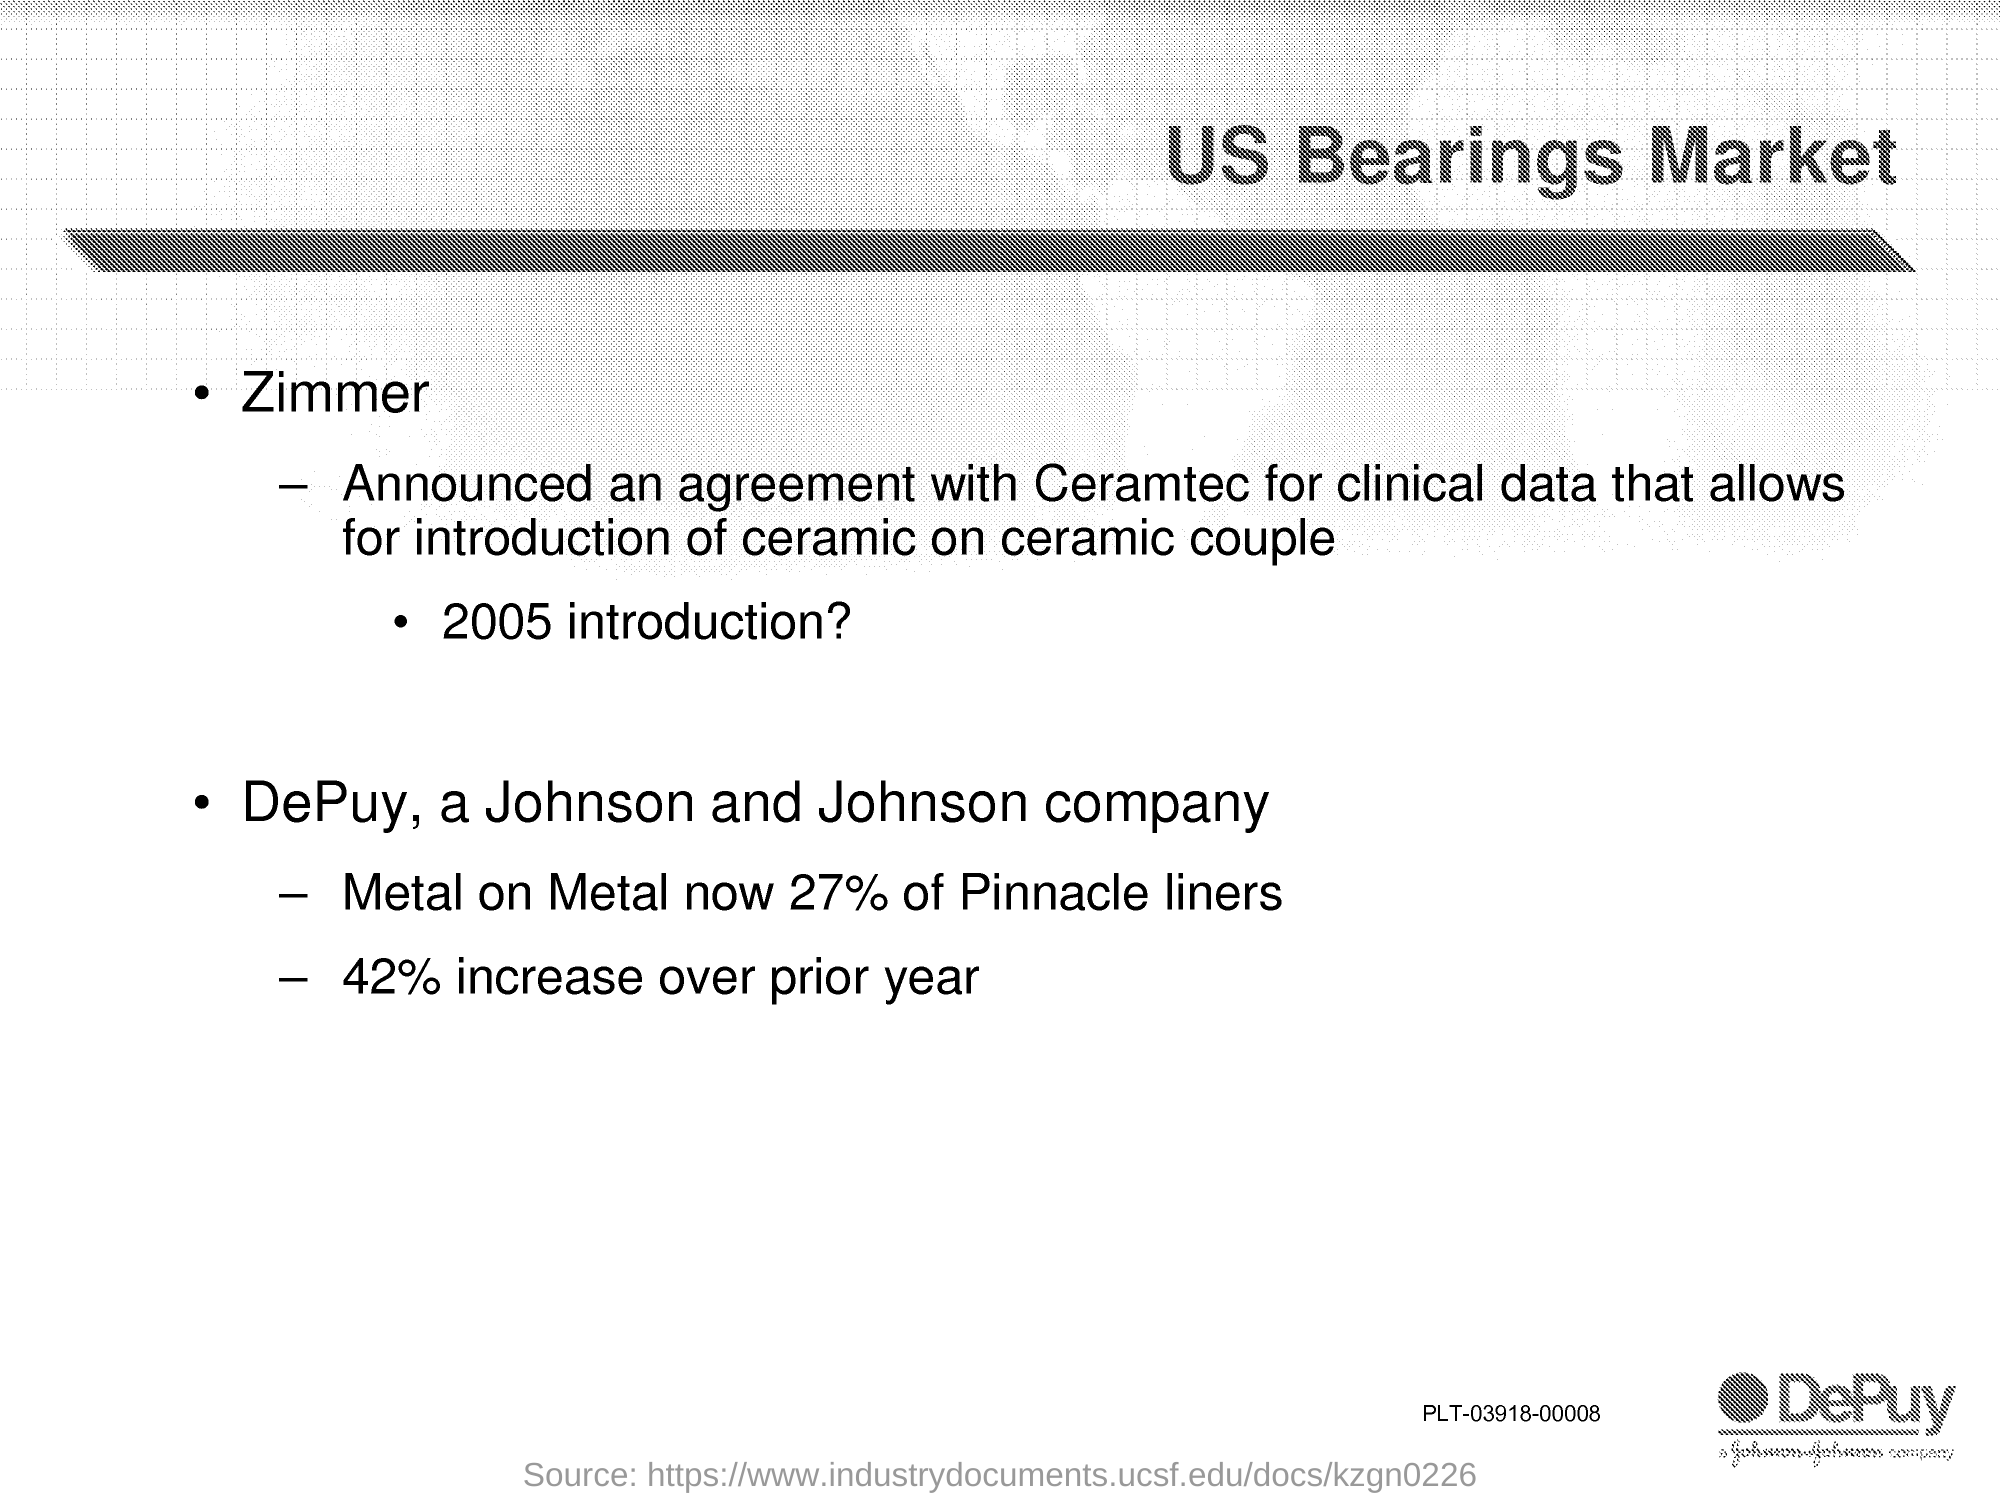What is the title of the document?
Provide a short and direct response. US Bearings Market. 